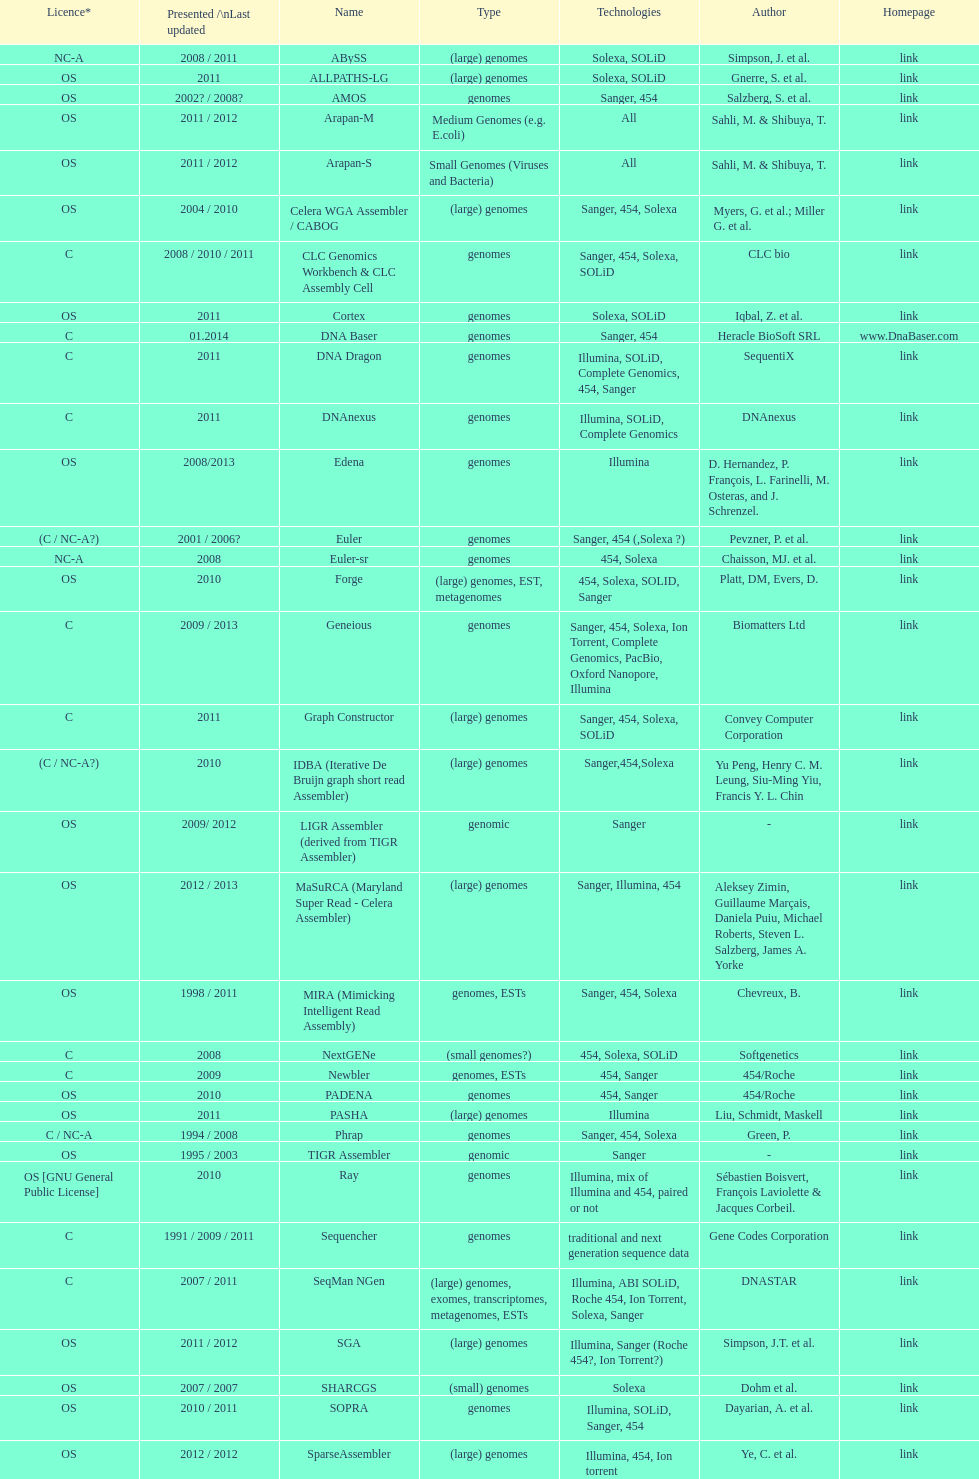What is the total number of assemblers supporting small genomes type technologies? 9. 